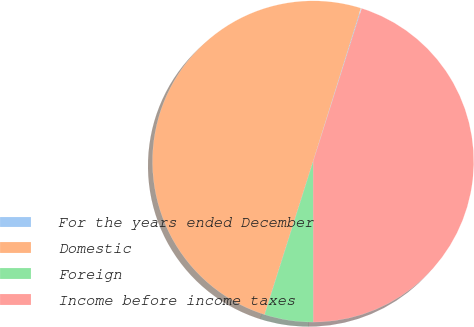Convert chart. <chart><loc_0><loc_0><loc_500><loc_500><pie_chart><fcel>For the years ended December<fcel>Domestic<fcel>Foreign<fcel>Income before income taxes<nl><fcel>0.08%<fcel>49.92%<fcel>4.9%<fcel>45.1%<nl></chart> 